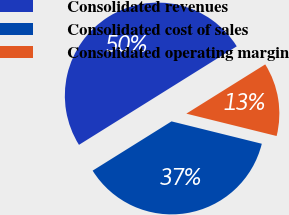Convert chart to OTSL. <chart><loc_0><loc_0><loc_500><loc_500><pie_chart><fcel>Consolidated revenues<fcel>Consolidated cost of sales<fcel>Consolidated operating margin<nl><fcel>50.0%<fcel>37.25%<fcel>12.75%<nl></chart> 